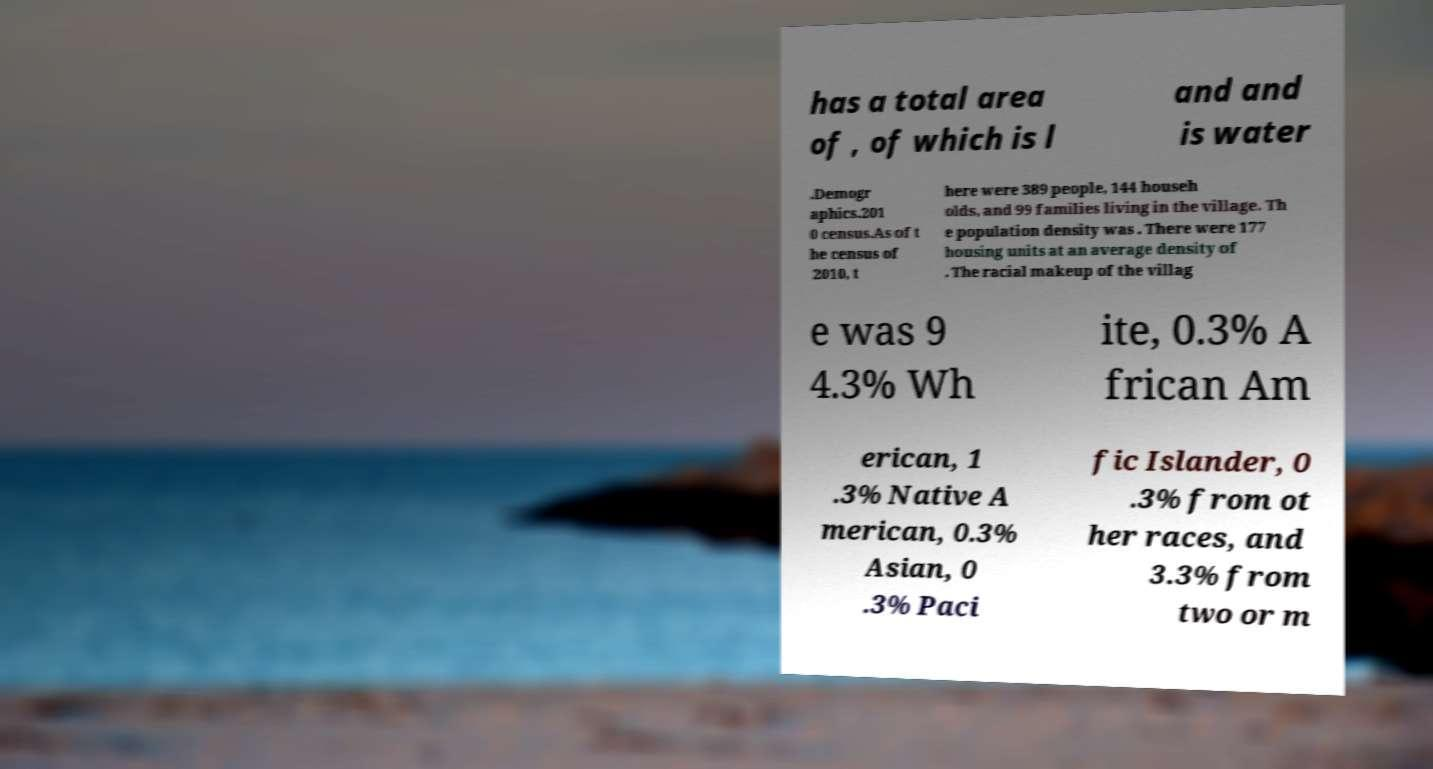What messages or text are displayed in this image? I need them in a readable, typed format. has a total area of , of which is l and and is water .Demogr aphics.201 0 census.As of t he census of 2010, t here were 389 people, 144 househ olds, and 99 families living in the village. Th e population density was . There were 177 housing units at an average density of . The racial makeup of the villag e was 9 4.3% Wh ite, 0.3% A frican Am erican, 1 .3% Native A merican, 0.3% Asian, 0 .3% Paci fic Islander, 0 .3% from ot her races, and 3.3% from two or m 